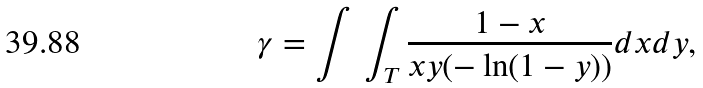<formula> <loc_0><loc_0><loc_500><loc_500>\gamma = { \int \, \int _ { T } { { \frac { 1 - x } { x y ( - \ln ( 1 - y ) ) } } } } d x d y ,</formula> 